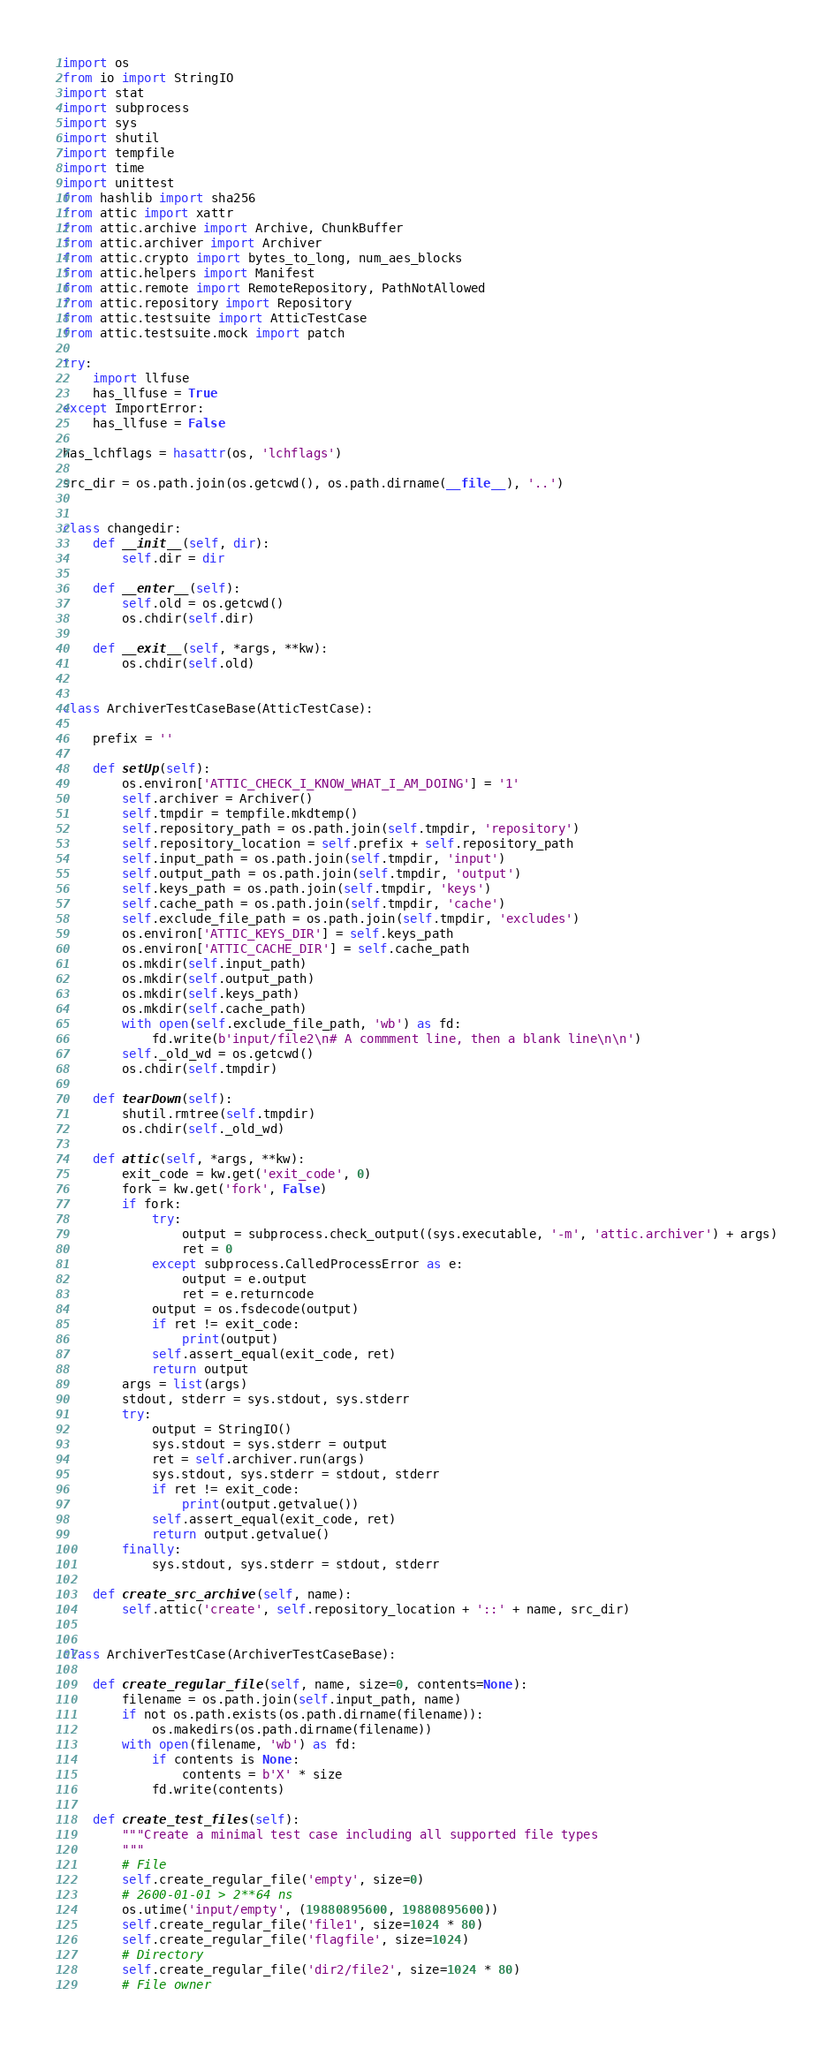Convert code to text. <code><loc_0><loc_0><loc_500><loc_500><_Python_>import os
from io import StringIO
import stat
import subprocess
import sys
import shutil
import tempfile
import time
import unittest
from hashlib import sha256
from attic import xattr
from attic.archive import Archive, ChunkBuffer
from attic.archiver import Archiver
from attic.crypto import bytes_to_long, num_aes_blocks
from attic.helpers import Manifest
from attic.remote import RemoteRepository, PathNotAllowed
from attic.repository import Repository
from attic.testsuite import AtticTestCase
from attic.testsuite.mock import patch

try:
    import llfuse
    has_llfuse = True
except ImportError:
    has_llfuse = False

has_lchflags = hasattr(os, 'lchflags')

src_dir = os.path.join(os.getcwd(), os.path.dirname(__file__), '..')


class changedir:
    def __init__(self, dir):
        self.dir = dir

    def __enter__(self):
        self.old = os.getcwd()
        os.chdir(self.dir)

    def __exit__(self, *args, **kw):
        os.chdir(self.old)


class ArchiverTestCaseBase(AtticTestCase):

    prefix = ''

    def setUp(self):
        os.environ['ATTIC_CHECK_I_KNOW_WHAT_I_AM_DOING'] = '1'
        self.archiver = Archiver()
        self.tmpdir = tempfile.mkdtemp()
        self.repository_path = os.path.join(self.tmpdir, 'repository')
        self.repository_location = self.prefix + self.repository_path
        self.input_path = os.path.join(self.tmpdir, 'input')
        self.output_path = os.path.join(self.tmpdir, 'output')
        self.keys_path = os.path.join(self.tmpdir, 'keys')
        self.cache_path = os.path.join(self.tmpdir, 'cache')
        self.exclude_file_path = os.path.join(self.tmpdir, 'excludes')
        os.environ['ATTIC_KEYS_DIR'] = self.keys_path
        os.environ['ATTIC_CACHE_DIR'] = self.cache_path
        os.mkdir(self.input_path)
        os.mkdir(self.output_path)
        os.mkdir(self.keys_path)
        os.mkdir(self.cache_path)
        with open(self.exclude_file_path, 'wb') as fd:
            fd.write(b'input/file2\n# A commment line, then a blank line\n\n')
        self._old_wd = os.getcwd()
        os.chdir(self.tmpdir)

    def tearDown(self):
        shutil.rmtree(self.tmpdir)
        os.chdir(self._old_wd)

    def attic(self, *args, **kw):
        exit_code = kw.get('exit_code', 0)
        fork = kw.get('fork', False)
        if fork:
            try:
                output = subprocess.check_output((sys.executable, '-m', 'attic.archiver') + args)
                ret = 0
            except subprocess.CalledProcessError as e:
                output = e.output
                ret = e.returncode
            output = os.fsdecode(output)
            if ret != exit_code:
                print(output)
            self.assert_equal(exit_code, ret)
            return output
        args = list(args)
        stdout, stderr = sys.stdout, sys.stderr
        try:
            output = StringIO()
            sys.stdout = sys.stderr = output
            ret = self.archiver.run(args)
            sys.stdout, sys.stderr = stdout, stderr
            if ret != exit_code:
                print(output.getvalue())
            self.assert_equal(exit_code, ret)
            return output.getvalue()
        finally:
            sys.stdout, sys.stderr = stdout, stderr

    def create_src_archive(self, name):
        self.attic('create', self.repository_location + '::' + name, src_dir)


class ArchiverTestCase(ArchiverTestCaseBase):

    def create_regular_file(self, name, size=0, contents=None):
        filename = os.path.join(self.input_path, name)
        if not os.path.exists(os.path.dirname(filename)):
            os.makedirs(os.path.dirname(filename))
        with open(filename, 'wb') as fd:
            if contents is None:
                contents = b'X' * size
            fd.write(contents)

    def create_test_files(self):
        """Create a minimal test case including all supported file types
        """
        # File
        self.create_regular_file('empty', size=0)
        # 2600-01-01 > 2**64 ns
        os.utime('input/empty', (19880895600, 19880895600))
        self.create_regular_file('file1', size=1024 * 80)
        self.create_regular_file('flagfile', size=1024)
        # Directory
        self.create_regular_file('dir2/file2', size=1024 * 80)
        # File owner</code> 